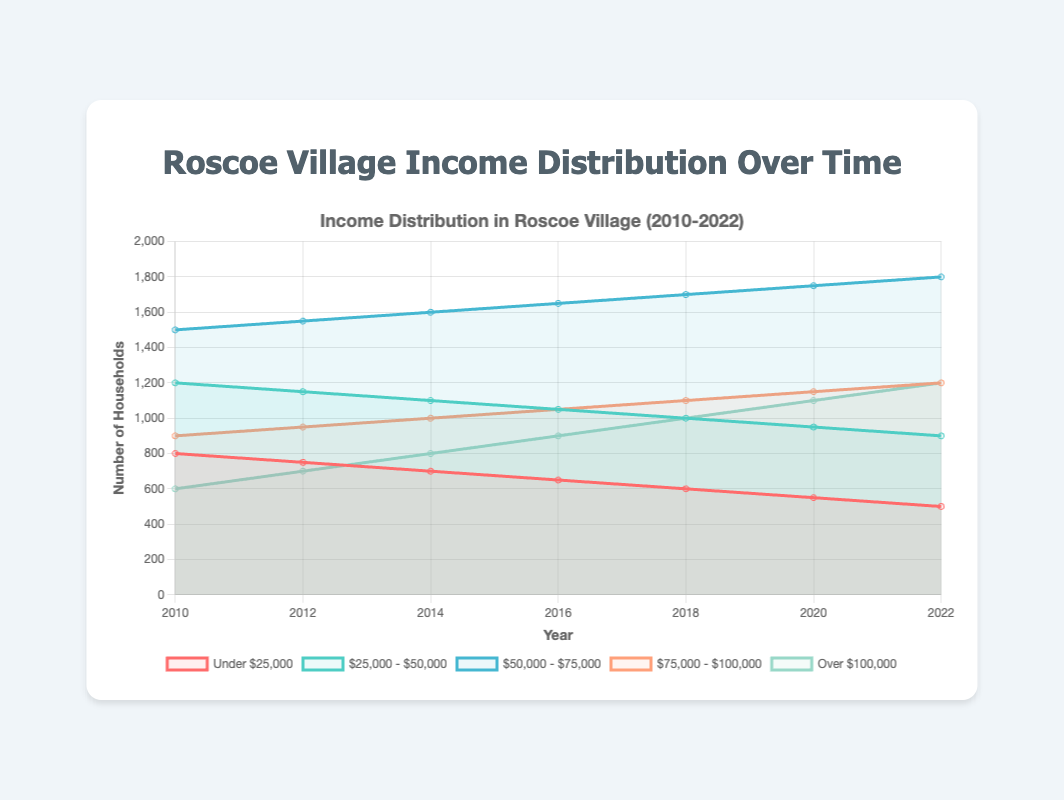What is the total number of households in Roscoe Village in 2022? The figure shows a line representing the number of households over different years. From the data at the end of the line for the year 2022, we can see that the number of households is 5600.
Answer: 5600 Which income bracket had the highest increase in the number of households from 2010 to 2022? By examining the trend lines for each income bracket from 2010 to 2022, we notice the steepest upwards slope is for the $50,000 to $75,000 bracket. The number of households increased from 1500 in 2010 to 1800 in 2022.
Answer: $50,000 to $75,000 Between which two consecutive years was the increase in the number of households earning over $100,000 the greatest? Comparing the increments between 2010-2012, 2012-2014, 2014-2016, 2016-2018, 2018-2020, and 2020-2022 for the over $100,000 bracket, the largest increase is observed between 2018 and 2020, where it rose from 1000 to 1100 households.
Answer: 2018-2020 What is the average number of households earning between $75,000 and $100,000 from 2010 to 2022? Summing up the households in the $75,000 to $100,000 bracket for all the years and then dividing by the number of years (7): (900 + 950 + 1000 + 1050 + 1100 + 1150 + 1200) / 7 = 7250 / 7 = 1035.71.
Answer: 1035.71 How did the number of households earning under $25,000 change from 2010 to 2022? Looking at the trend for the under $25,000 bracket, the number decreased from 800 in 2010 to 500 in 2022.
Answer: Decreased Which income bracket had the least change in the number of households from 2010 to 2022? The $25,000 to $50,000 bracket had a steady decline from 1200 in 2010 to 900 in 2022, which is the least change among the income brackets.
Answer: $25,000 to $50,000 How does the household number of the highest income bracket in 2022 compare to the total households in 2010? The number of households earning over $100,000 in 2022 is 1200. Total households in 2010 are 5000. Thus, the highest income bracket in 2022 (1200) is less than the total households in 2010 (5000).
Answer: Less than Which color represents the income bracket of $50,000 to $75,000? By referring to the legend in the figure, the $50,000 to $75,000 bracket is represented by a blue line.
Answer: Blue What is the difference in the number of households earning over $100,000 between 2010 and 2022? The number of households earning over $100,000 was 600 in 2010 and increased to 1200 in 2022. The difference is 1200 - 600 = 600.
Answer: 600 